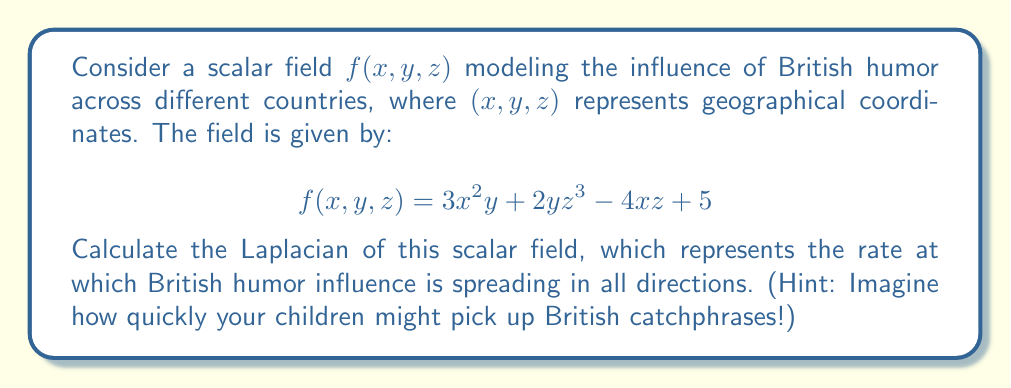Give your solution to this math problem. To calculate the Laplacian of the scalar field $f(x,y,z)$, we need to follow these steps:

1. Recall that the Laplacian in 3D Cartesian coordinates is given by:

   $$\nabla^2f = \frac{\partial^2f}{\partial x^2} + \frac{\partial^2f}{\partial y^2} + \frac{\partial^2f}{\partial z^2}$$

2. Calculate $\frac{\partial^2f}{\partial x^2}$:
   First, $\frac{\partial f}{\partial x} = 6xy - 4z$
   Then, $\frac{\partial^2f}{\partial x^2} = 6y$

3. Calculate $\frac{\partial^2f}{\partial y^2}$:
   First, $\frac{\partial f}{\partial y} = 3x^2 + 2z^3$
   Then, $\frac{\partial^2f}{\partial y^2} = 0$

4. Calculate $\frac{\partial^2f}{\partial z^2}$:
   First, $\frac{\partial f}{\partial z} = 6yz^2 - 4x$
   Then, $\frac{\partial^2f}{\partial z^2} = 12yz$

5. Sum up the results:
   $$\nabla^2f = \frac{\partial^2f}{\partial x^2} + \frac{\partial^2f}{\partial y^2} + \frac{\partial^2f}{\partial z^2}$$
   $$\nabla^2f = 6y + 0 + 12yz$$
   $$\nabla^2f = 6y + 12yz$$

6. Simplify:
   $$\nabla^2f = 6y(1 + 2z)$$

This result represents the rate at which British humor influence is spreading in all directions at any point $(x,y,z)$.
Answer: $6y(1 + 2z)$ 